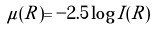<formula> <loc_0><loc_0><loc_500><loc_500>\mu ( R ) = - 2 . 5 \log { I ( R ) }</formula> 